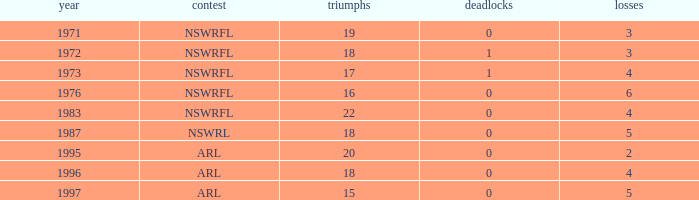What average Loses has Draws less than 0? None. 